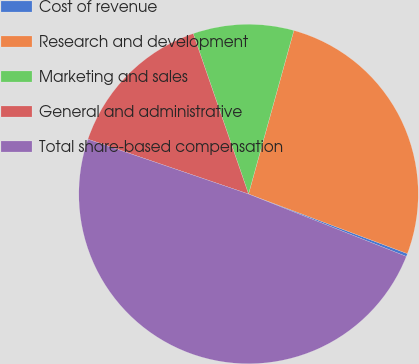Convert chart to OTSL. <chart><loc_0><loc_0><loc_500><loc_500><pie_chart><fcel>Cost of revenue<fcel>Research and development<fcel>Marketing and sales<fcel>General and administrative<fcel>Total share-based compensation<nl><fcel>0.28%<fcel>26.41%<fcel>9.59%<fcel>14.48%<fcel>49.24%<nl></chart> 